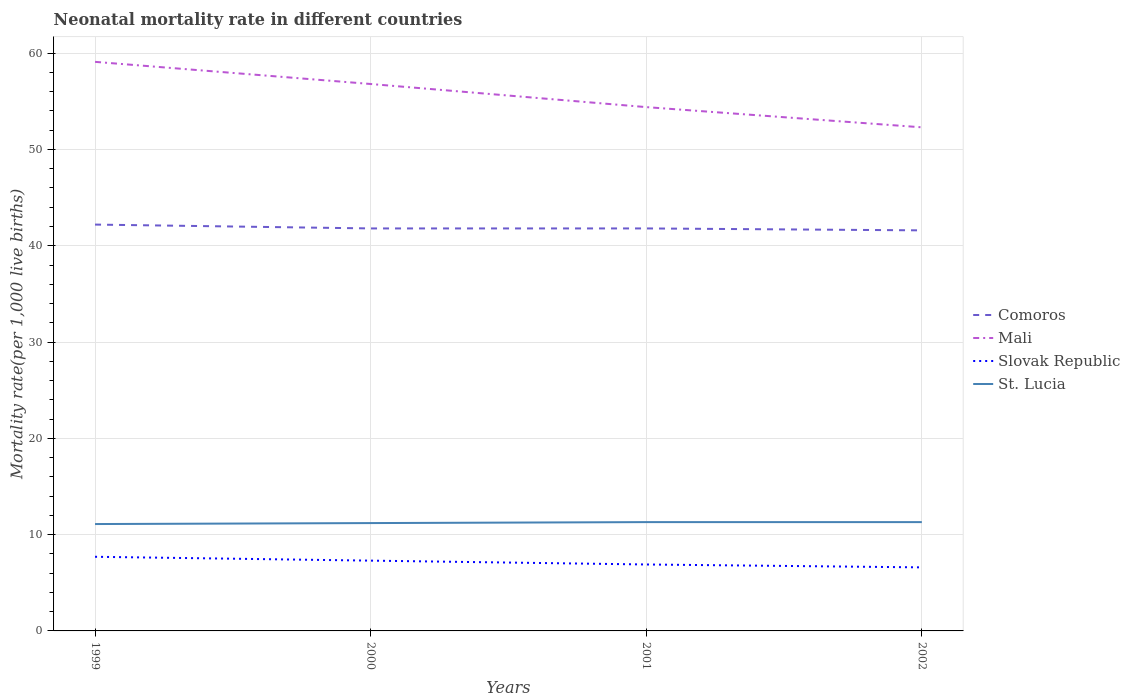How many different coloured lines are there?
Provide a succinct answer. 4. Does the line corresponding to Slovak Republic intersect with the line corresponding to Comoros?
Ensure brevity in your answer.  No. Across all years, what is the maximum neonatal mortality rate in Comoros?
Make the answer very short. 41.6. What is the total neonatal mortality rate in Comoros in the graph?
Your response must be concise. 0.4. What is the difference between the highest and the second highest neonatal mortality rate in St. Lucia?
Make the answer very short. 0.2. Is the neonatal mortality rate in Comoros strictly greater than the neonatal mortality rate in Mali over the years?
Make the answer very short. Yes. What is the difference between two consecutive major ticks on the Y-axis?
Provide a succinct answer. 10. Where does the legend appear in the graph?
Offer a very short reply. Center right. How are the legend labels stacked?
Your answer should be very brief. Vertical. What is the title of the graph?
Keep it short and to the point. Neonatal mortality rate in different countries. What is the label or title of the X-axis?
Your response must be concise. Years. What is the label or title of the Y-axis?
Give a very brief answer. Mortality rate(per 1,0 live births). What is the Mortality rate(per 1,000 live births) of Comoros in 1999?
Offer a terse response. 42.2. What is the Mortality rate(per 1,000 live births) in Mali in 1999?
Provide a succinct answer. 59.1. What is the Mortality rate(per 1,000 live births) of Slovak Republic in 1999?
Provide a succinct answer. 7.7. What is the Mortality rate(per 1,000 live births) of St. Lucia in 1999?
Your answer should be compact. 11.1. What is the Mortality rate(per 1,000 live births) of Comoros in 2000?
Give a very brief answer. 41.8. What is the Mortality rate(per 1,000 live births) in Mali in 2000?
Make the answer very short. 56.8. What is the Mortality rate(per 1,000 live births) in Comoros in 2001?
Keep it short and to the point. 41.8. What is the Mortality rate(per 1,000 live births) of Mali in 2001?
Give a very brief answer. 54.4. What is the Mortality rate(per 1,000 live births) of St. Lucia in 2001?
Ensure brevity in your answer.  11.3. What is the Mortality rate(per 1,000 live births) of Comoros in 2002?
Keep it short and to the point. 41.6. What is the Mortality rate(per 1,000 live births) in Mali in 2002?
Provide a short and direct response. 52.3. What is the Mortality rate(per 1,000 live births) in Slovak Republic in 2002?
Provide a short and direct response. 6.6. Across all years, what is the maximum Mortality rate(per 1,000 live births) of Comoros?
Keep it short and to the point. 42.2. Across all years, what is the maximum Mortality rate(per 1,000 live births) of Mali?
Offer a terse response. 59.1. Across all years, what is the maximum Mortality rate(per 1,000 live births) of Slovak Republic?
Offer a terse response. 7.7. Across all years, what is the maximum Mortality rate(per 1,000 live births) in St. Lucia?
Your answer should be compact. 11.3. Across all years, what is the minimum Mortality rate(per 1,000 live births) in Comoros?
Your response must be concise. 41.6. Across all years, what is the minimum Mortality rate(per 1,000 live births) of Mali?
Make the answer very short. 52.3. Across all years, what is the minimum Mortality rate(per 1,000 live births) in Slovak Republic?
Offer a terse response. 6.6. What is the total Mortality rate(per 1,000 live births) of Comoros in the graph?
Make the answer very short. 167.4. What is the total Mortality rate(per 1,000 live births) in Mali in the graph?
Your response must be concise. 222.6. What is the total Mortality rate(per 1,000 live births) of St. Lucia in the graph?
Keep it short and to the point. 44.9. What is the difference between the Mortality rate(per 1,000 live births) of Mali in 1999 and that in 2000?
Offer a very short reply. 2.3. What is the difference between the Mortality rate(per 1,000 live births) in Slovak Republic in 1999 and that in 2000?
Offer a very short reply. 0.4. What is the difference between the Mortality rate(per 1,000 live births) in Mali in 1999 and that in 2001?
Make the answer very short. 4.7. What is the difference between the Mortality rate(per 1,000 live births) in Slovak Republic in 1999 and that in 2001?
Provide a succinct answer. 0.8. What is the difference between the Mortality rate(per 1,000 live births) of St. Lucia in 1999 and that in 2001?
Your answer should be very brief. -0.2. What is the difference between the Mortality rate(per 1,000 live births) in Comoros in 1999 and that in 2002?
Your answer should be compact. 0.6. What is the difference between the Mortality rate(per 1,000 live births) in Mali in 1999 and that in 2002?
Keep it short and to the point. 6.8. What is the difference between the Mortality rate(per 1,000 live births) in Slovak Republic in 1999 and that in 2002?
Provide a short and direct response. 1.1. What is the difference between the Mortality rate(per 1,000 live births) of Slovak Republic in 2000 and that in 2001?
Ensure brevity in your answer.  0.4. What is the difference between the Mortality rate(per 1,000 live births) of Comoros in 2000 and that in 2002?
Your answer should be very brief. 0.2. What is the difference between the Mortality rate(per 1,000 live births) in Mali in 2000 and that in 2002?
Keep it short and to the point. 4.5. What is the difference between the Mortality rate(per 1,000 live births) of Comoros in 2001 and that in 2002?
Keep it short and to the point. 0.2. What is the difference between the Mortality rate(per 1,000 live births) of Slovak Republic in 2001 and that in 2002?
Your answer should be very brief. 0.3. What is the difference between the Mortality rate(per 1,000 live births) of St. Lucia in 2001 and that in 2002?
Ensure brevity in your answer.  0. What is the difference between the Mortality rate(per 1,000 live births) in Comoros in 1999 and the Mortality rate(per 1,000 live births) in Mali in 2000?
Make the answer very short. -14.6. What is the difference between the Mortality rate(per 1,000 live births) in Comoros in 1999 and the Mortality rate(per 1,000 live births) in Slovak Republic in 2000?
Provide a short and direct response. 34.9. What is the difference between the Mortality rate(per 1,000 live births) of Comoros in 1999 and the Mortality rate(per 1,000 live births) of St. Lucia in 2000?
Ensure brevity in your answer.  31. What is the difference between the Mortality rate(per 1,000 live births) in Mali in 1999 and the Mortality rate(per 1,000 live births) in Slovak Republic in 2000?
Keep it short and to the point. 51.8. What is the difference between the Mortality rate(per 1,000 live births) of Mali in 1999 and the Mortality rate(per 1,000 live births) of St. Lucia in 2000?
Offer a terse response. 47.9. What is the difference between the Mortality rate(per 1,000 live births) of Comoros in 1999 and the Mortality rate(per 1,000 live births) of Slovak Republic in 2001?
Make the answer very short. 35.3. What is the difference between the Mortality rate(per 1,000 live births) of Comoros in 1999 and the Mortality rate(per 1,000 live births) of St. Lucia in 2001?
Ensure brevity in your answer.  30.9. What is the difference between the Mortality rate(per 1,000 live births) in Mali in 1999 and the Mortality rate(per 1,000 live births) in Slovak Republic in 2001?
Provide a succinct answer. 52.2. What is the difference between the Mortality rate(per 1,000 live births) in Mali in 1999 and the Mortality rate(per 1,000 live births) in St. Lucia in 2001?
Offer a very short reply. 47.8. What is the difference between the Mortality rate(per 1,000 live births) of Slovak Republic in 1999 and the Mortality rate(per 1,000 live births) of St. Lucia in 2001?
Offer a terse response. -3.6. What is the difference between the Mortality rate(per 1,000 live births) in Comoros in 1999 and the Mortality rate(per 1,000 live births) in Slovak Republic in 2002?
Provide a succinct answer. 35.6. What is the difference between the Mortality rate(per 1,000 live births) in Comoros in 1999 and the Mortality rate(per 1,000 live births) in St. Lucia in 2002?
Provide a succinct answer. 30.9. What is the difference between the Mortality rate(per 1,000 live births) of Mali in 1999 and the Mortality rate(per 1,000 live births) of Slovak Republic in 2002?
Your answer should be very brief. 52.5. What is the difference between the Mortality rate(per 1,000 live births) in Mali in 1999 and the Mortality rate(per 1,000 live births) in St. Lucia in 2002?
Provide a succinct answer. 47.8. What is the difference between the Mortality rate(per 1,000 live births) of Slovak Republic in 1999 and the Mortality rate(per 1,000 live births) of St. Lucia in 2002?
Your response must be concise. -3.6. What is the difference between the Mortality rate(per 1,000 live births) of Comoros in 2000 and the Mortality rate(per 1,000 live births) of Slovak Republic in 2001?
Ensure brevity in your answer.  34.9. What is the difference between the Mortality rate(per 1,000 live births) of Comoros in 2000 and the Mortality rate(per 1,000 live births) of St. Lucia in 2001?
Give a very brief answer. 30.5. What is the difference between the Mortality rate(per 1,000 live births) in Mali in 2000 and the Mortality rate(per 1,000 live births) in Slovak Republic in 2001?
Ensure brevity in your answer.  49.9. What is the difference between the Mortality rate(per 1,000 live births) in Mali in 2000 and the Mortality rate(per 1,000 live births) in St. Lucia in 2001?
Give a very brief answer. 45.5. What is the difference between the Mortality rate(per 1,000 live births) of Comoros in 2000 and the Mortality rate(per 1,000 live births) of Slovak Republic in 2002?
Your response must be concise. 35.2. What is the difference between the Mortality rate(per 1,000 live births) of Comoros in 2000 and the Mortality rate(per 1,000 live births) of St. Lucia in 2002?
Your response must be concise. 30.5. What is the difference between the Mortality rate(per 1,000 live births) in Mali in 2000 and the Mortality rate(per 1,000 live births) in Slovak Republic in 2002?
Your answer should be very brief. 50.2. What is the difference between the Mortality rate(per 1,000 live births) in Mali in 2000 and the Mortality rate(per 1,000 live births) in St. Lucia in 2002?
Your answer should be compact. 45.5. What is the difference between the Mortality rate(per 1,000 live births) of Comoros in 2001 and the Mortality rate(per 1,000 live births) of Mali in 2002?
Keep it short and to the point. -10.5. What is the difference between the Mortality rate(per 1,000 live births) of Comoros in 2001 and the Mortality rate(per 1,000 live births) of Slovak Republic in 2002?
Ensure brevity in your answer.  35.2. What is the difference between the Mortality rate(per 1,000 live births) of Comoros in 2001 and the Mortality rate(per 1,000 live births) of St. Lucia in 2002?
Provide a short and direct response. 30.5. What is the difference between the Mortality rate(per 1,000 live births) of Mali in 2001 and the Mortality rate(per 1,000 live births) of Slovak Republic in 2002?
Your answer should be very brief. 47.8. What is the difference between the Mortality rate(per 1,000 live births) of Mali in 2001 and the Mortality rate(per 1,000 live births) of St. Lucia in 2002?
Offer a terse response. 43.1. What is the average Mortality rate(per 1,000 live births) of Comoros per year?
Your answer should be very brief. 41.85. What is the average Mortality rate(per 1,000 live births) of Mali per year?
Your response must be concise. 55.65. What is the average Mortality rate(per 1,000 live births) of Slovak Republic per year?
Your response must be concise. 7.12. What is the average Mortality rate(per 1,000 live births) of St. Lucia per year?
Give a very brief answer. 11.22. In the year 1999, what is the difference between the Mortality rate(per 1,000 live births) in Comoros and Mortality rate(per 1,000 live births) in Mali?
Provide a short and direct response. -16.9. In the year 1999, what is the difference between the Mortality rate(per 1,000 live births) in Comoros and Mortality rate(per 1,000 live births) in Slovak Republic?
Keep it short and to the point. 34.5. In the year 1999, what is the difference between the Mortality rate(per 1,000 live births) in Comoros and Mortality rate(per 1,000 live births) in St. Lucia?
Offer a terse response. 31.1. In the year 1999, what is the difference between the Mortality rate(per 1,000 live births) in Mali and Mortality rate(per 1,000 live births) in Slovak Republic?
Provide a short and direct response. 51.4. In the year 1999, what is the difference between the Mortality rate(per 1,000 live births) in Mali and Mortality rate(per 1,000 live births) in St. Lucia?
Make the answer very short. 48. In the year 2000, what is the difference between the Mortality rate(per 1,000 live births) in Comoros and Mortality rate(per 1,000 live births) in Mali?
Provide a succinct answer. -15. In the year 2000, what is the difference between the Mortality rate(per 1,000 live births) in Comoros and Mortality rate(per 1,000 live births) in Slovak Republic?
Your answer should be compact. 34.5. In the year 2000, what is the difference between the Mortality rate(per 1,000 live births) of Comoros and Mortality rate(per 1,000 live births) of St. Lucia?
Provide a short and direct response. 30.6. In the year 2000, what is the difference between the Mortality rate(per 1,000 live births) of Mali and Mortality rate(per 1,000 live births) of Slovak Republic?
Offer a very short reply. 49.5. In the year 2000, what is the difference between the Mortality rate(per 1,000 live births) of Mali and Mortality rate(per 1,000 live births) of St. Lucia?
Ensure brevity in your answer.  45.6. In the year 2000, what is the difference between the Mortality rate(per 1,000 live births) in Slovak Republic and Mortality rate(per 1,000 live births) in St. Lucia?
Ensure brevity in your answer.  -3.9. In the year 2001, what is the difference between the Mortality rate(per 1,000 live births) in Comoros and Mortality rate(per 1,000 live births) in Slovak Republic?
Make the answer very short. 34.9. In the year 2001, what is the difference between the Mortality rate(per 1,000 live births) of Comoros and Mortality rate(per 1,000 live births) of St. Lucia?
Keep it short and to the point. 30.5. In the year 2001, what is the difference between the Mortality rate(per 1,000 live births) of Mali and Mortality rate(per 1,000 live births) of Slovak Republic?
Make the answer very short. 47.5. In the year 2001, what is the difference between the Mortality rate(per 1,000 live births) of Mali and Mortality rate(per 1,000 live births) of St. Lucia?
Make the answer very short. 43.1. In the year 2002, what is the difference between the Mortality rate(per 1,000 live births) in Comoros and Mortality rate(per 1,000 live births) in Mali?
Offer a very short reply. -10.7. In the year 2002, what is the difference between the Mortality rate(per 1,000 live births) in Comoros and Mortality rate(per 1,000 live births) in Slovak Republic?
Your response must be concise. 35. In the year 2002, what is the difference between the Mortality rate(per 1,000 live births) of Comoros and Mortality rate(per 1,000 live births) of St. Lucia?
Ensure brevity in your answer.  30.3. In the year 2002, what is the difference between the Mortality rate(per 1,000 live births) in Mali and Mortality rate(per 1,000 live births) in Slovak Republic?
Your answer should be very brief. 45.7. What is the ratio of the Mortality rate(per 1,000 live births) in Comoros in 1999 to that in 2000?
Your response must be concise. 1.01. What is the ratio of the Mortality rate(per 1,000 live births) of Mali in 1999 to that in 2000?
Provide a short and direct response. 1.04. What is the ratio of the Mortality rate(per 1,000 live births) of Slovak Republic in 1999 to that in 2000?
Offer a very short reply. 1.05. What is the ratio of the Mortality rate(per 1,000 live births) of Comoros in 1999 to that in 2001?
Provide a short and direct response. 1.01. What is the ratio of the Mortality rate(per 1,000 live births) of Mali in 1999 to that in 2001?
Ensure brevity in your answer.  1.09. What is the ratio of the Mortality rate(per 1,000 live births) of Slovak Republic in 1999 to that in 2001?
Provide a succinct answer. 1.12. What is the ratio of the Mortality rate(per 1,000 live births) in St. Lucia in 1999 to that in 2001?
Your answer should be compact. 0.98. What is the ratio of the Mortality rate(per 1,000 live births) of Comoros in 1999 to that in 2002?
Keep it short and to the point. 1.01. What is the ratio of the Mortality rate(per 1,000 live births) in Mali in 1999 to that in 2002?
Offer a terse response. 1.13. What is the ratio of the Mortality rate(per 1,000 live births) of Slovak Republic in 1999 to that in 2002?
Provide a short and direct response. 1.17. What is the ratio of the Mortality rate(per 1,000 live births) of St. Lucia in 1999 to that in 2002?
Your answer should be compact. 0.98. What is the ratio of the Mortality rate(per 1,000 live births) of Mali in 2000 to that in 2001?
Your answer should be very brief. 1.04. What is the ratio of the Mortality rate(per 1,000 live births) in Slovak Republic in 2000 to that in 2001?
Your response must be concise. 1.06. What is the ratio of the Mortality rate(per 1,000 live births) of St. Lucia in 2000 to that in 2001?
Offer a terse response. 0.99. What is the ratio of the Mortality rate(per 1,000 live births) in Mali in 2000 to that in 2002?
Offer a very short reply. 1.09. What is the ratio of the Mortality rate(per 1,000 live births) of Slovak Republic in 2000 to that in 2002?
Give a very brief answer. 1.11. What is the ratio of the Mortality rate(per 1,000 live births) in Comoros in 2001 to that in 2002?
Provide a short and direct response. 1. What is the ratio of the Mortality rate(per 1,000 live births) in Mali in 2001 to that in 2002?
Offer a very short reply. 1.04. What is the ratio of the Mortality rate(per 1,000 live births) in Slovak Republic in 2001 to that in 2002?
Provide a short and direct response. 1.05. What is the difference between the highest and the lowest Mortality rate(per 1,000 live births) of Mali?
Give a very brief answer. 6.8. What is the difference between the highest and the lowest Mortality rate(per 1,000 live births) of St. Lucia?
Offer a very short reply. 0.2. 